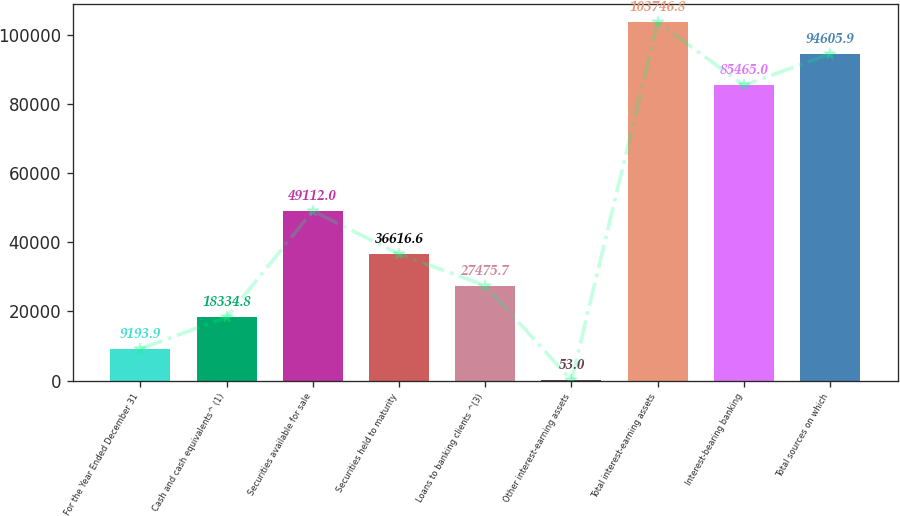<chart> <loc_0><loc_0><loc_500><loc_500><bar_chart><fcel>For the Year Ended December 31<fcel>Cash and cash equivalents^ (1)<fcel>Securities available for sale<fcel>Securities held to maturity<fcel>Loans to banking clients ^(3)<fcel>Other interest-earning assets<fcel>Total interest-earning assets<fcel>Interest-bearing banking<fcel>Total sources on which<nl><fcel>9193.9<fcel>18334.8<fcel>49112<fcel>36616.6<fcel>27475.7<fcel>53<fcel>103747<fcel>85465<fcel>94605.9<nl></chart> 